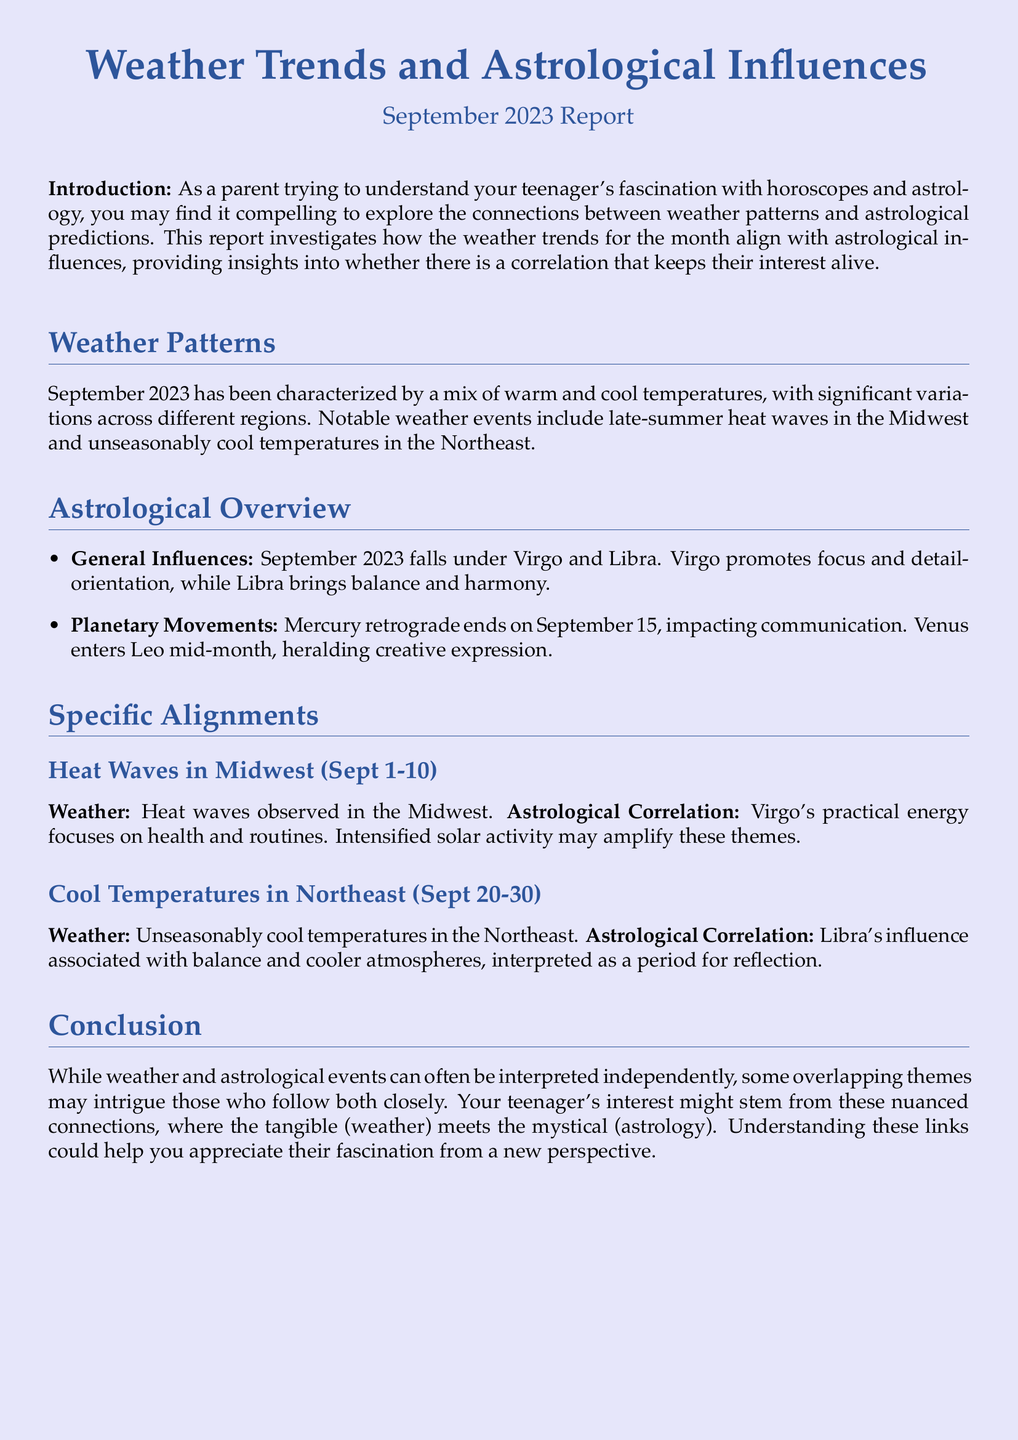What was the primary focus of Virgo in September 2023? Virgo promotes focus and detail-orientation during September.
Answer: Focus and detail-orientation What were the notable weather events in September 2023? The document mentions heat waves in the Midwest and cool temperatures in the Northeast.
Answer: Heat waves and cool temperatures What date did Mercury retrograde end in September 2023? Mercury retrograde ended on September 15, impacting communication.
Answer: September 15 What zodiac sign influences the cooler temperatures in the Northeast? Libra's influence is associated with balance and cooler atmospheres.
Answer: Libra What happens to Venus mid-month? Venus enters Leo mid-month, heralding creative expression.
Answer: Enters Leo What is the weather pattern for the Midwest from September 1-10? The Midwest experienced heat waves during this period.
Answer: Heat waves What might the intense solar activity amplify according to the report? Intense solar activity may amplify health and routine themes in alignment with Virgo.
Answer: Health and routines What is the color theme of the document? The document features a color theme of astral blue and mystical lavender.
Answer: Astral blue and mystical lavender 